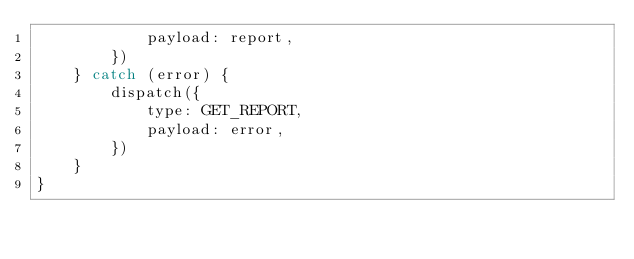Convert code to text. <code><loc_0><loc_0><loc_500><loc_500><_JavaScript_>            payload: report,
        })
    } catch (error) {
        dispatch({
            type: GET_REPORT,
            payload: error,
        })
    }
}
</code> 